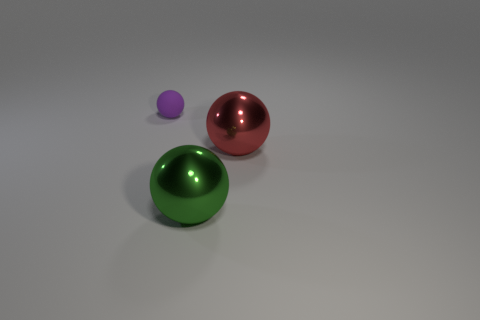Add 1 red shiny things. How many objects exist? 4 Subtract 0 purple cylinders. How many objects are left? 3 Subtract all shiny balls. Subtract all small red metallic cubes. How many objects are left? 1 Add 3 red things. How many red things are left? 4 Add 3 spheres. How many spheres exist? 6 